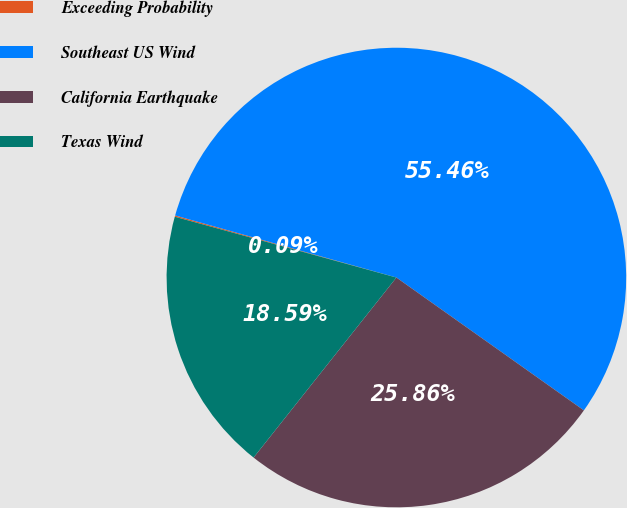Convert chart to OTSL. <chart><loc_0><loc_0><loc_500><loc_500><pie_chart><fcel>Exceeding Probability<fcel>Southeast US Wind<fcel>California Earthquake<fcel>Texas Wind<nl><fcel>0.09%<fcel>55.46%<fcel>25.86%<fcel>18.59%<nl></chart> 